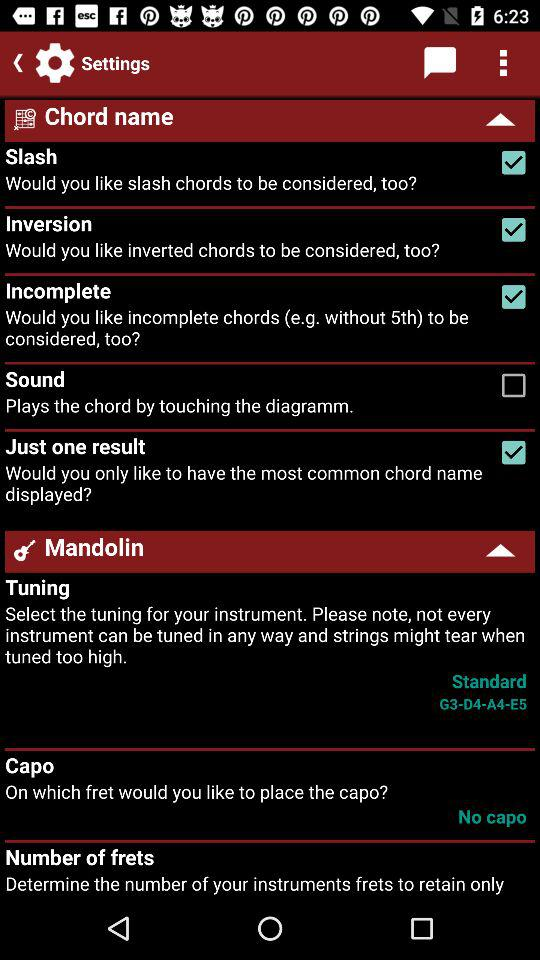What description is given in the sound setting? The given description is that it plays the chord by touching the diagramm. 